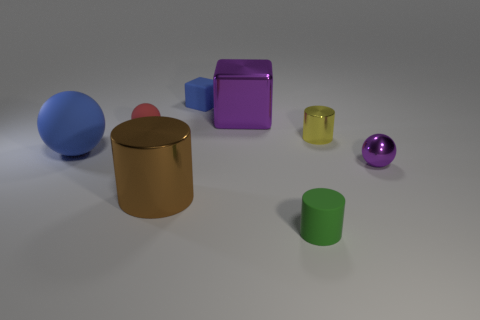Subtract all small yellow cylinders. How many cylinders are left? 2 Add 1 small yellow cylinders. How many objects exist? 9 Subtract 1 spheres. How many spheres are left? 2 Subtract all cylinders. How many objects are left? 5 Subtract all yellow cylinders. Subtract all green matte objects. How many objects are left? 6 Add 3 red rubber things. How many red rubber things are left? 4 Add 1 large cylinders. How many large cylinders exist? 2 Subtract 0 red cubes. How many objects are left? 8 Subtract all green cubes. Subtract all red spheres. How many cubes are left? 2 